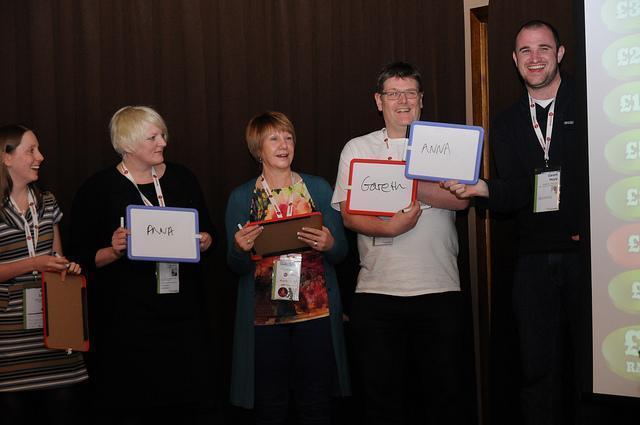How many people can be seen?
Give a very brief answer. 5. 